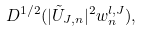Convert formula to latex. <formula><loc_0><loc_0><loc_500><loc_500>D ^ { 1 / 2 } ( | \tilde { U } _ { J , n } | ^ { 2 } w _ { n } ^ { l , J } ) ,</formula> 